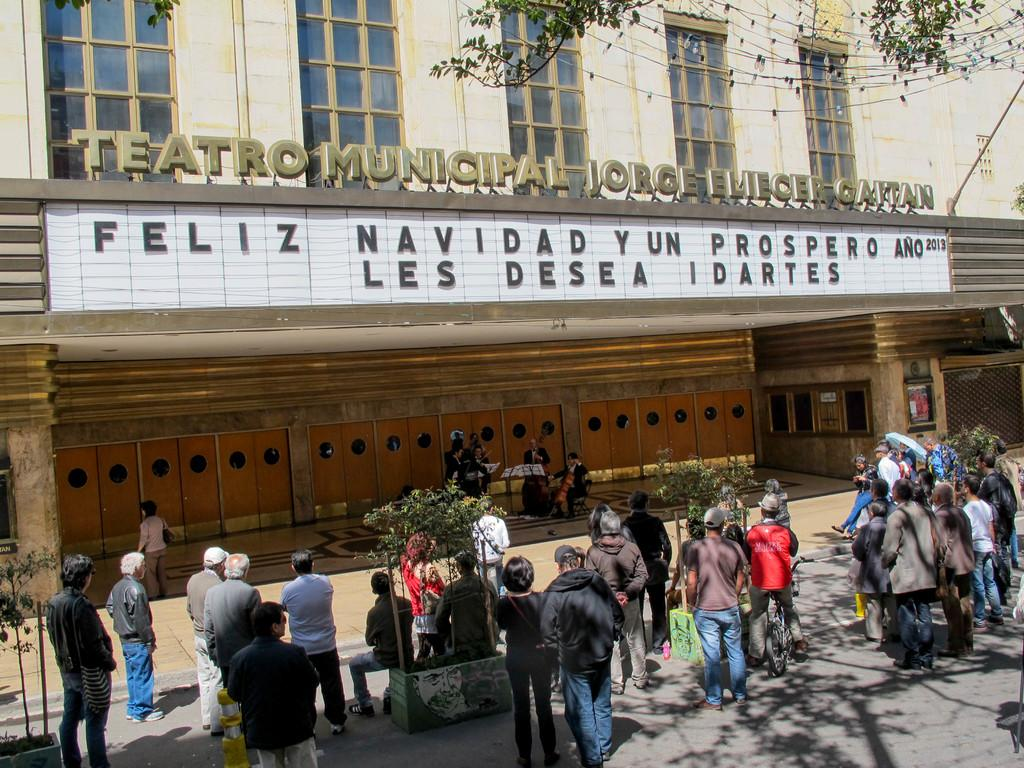How many groups of people can be seen in the image? There are two groups of people in the image. What are the people in the second group doing? The second group of people is standing and holding musical instruments. What type of object is visible in the image that is used for transportation? There is a bicycle in the image. What can be seen in the image that might be used for decoration or illumination? There is rope light in the image. What type of structure is visible in the image? There is a building in the image. What type of toothbrush is being used by the person in the image? There is no toothbrush present in the image. What historical event is being depicted in the image? There is no historical event being depicted in the image. 